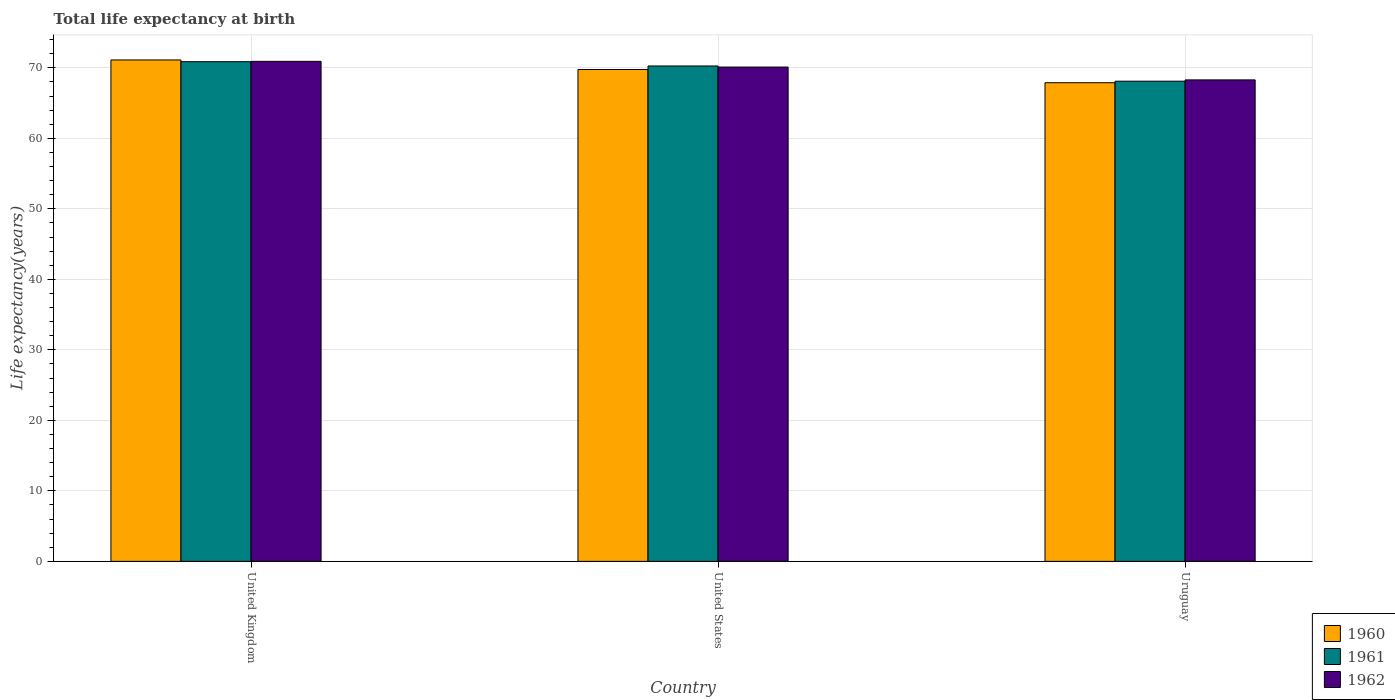How many groups of bars are there?
Offer a very short reply. 3. Are the number of bars on each tick of the X-axis equal?
Keep it short and to the point. Yes. How many bars are there on the 1st tick from the left?
Offer a very short reply. 3. How many bars are there on the 1st tick from the right?
Ensure brevity in your answer.  3. What is the life expectancy at birth in in 1961 in United Kingdom?
Offer a terse response. 70.88. Across all countries, what is the maximum life expectancy at birth in in 1962?
Your answer should be very brief. 70.93. Across all countries, what is the minimum life expectancy at birth in in 1961?
Provide a succinct answer. 68.11. In which country was the life expectancy at birth in in 1961 minimum?
Give a very brief answer. Uruguay. What is the total life expectancy at birth in in 1962 in the graph?
Provide a succinct answer. 209.34. What is the difference between the life expectancy at birth in in 1960 in United States and that in Uruguay?
Ensure brevity in your answer.  1.87. What is the difference between the life expectancy at birth in in 1961 in Uruguay and the life expectancy at birth in in 1960 in United States?
Offer a very short reply. -1.66. What is the average life expectancy at birth in in 1960 per country?
Offer a terse response. 69.6. What is the difference between the life expectancy at birth in of/in 1961 and life expectancy at birth in of/in 1960 in United States?
Give a very brief answer. 0.5. What is the ratio of the life expectancy at birth in in 1961 in United States to that in Uruguay?
Offer a terse response. 1.03. Is the difference between the life expectancy at birth in in 1961 in United States and Uruguay greater than the difference between the life expectancy at birth in in 1960 in United States and Uruguay?
Your answer should be very brief. Yes. What is the difference between the highest and the second highest life expectancy at birth in in 1962?
Offer a very short reply. 1.82. What is the difference between the highest and the lowest life expectancy at birth in in 1961?
Provide a short and direct response. 2.77. In how many countries, is the life expectancy at birth in in 1961 greater than the average life expectancy at birth in in 1961 taken over all countries?
Give a very brief answer. 2. What does the 1st bar from the left in United States represents?
Ensure brevity in your answer.  1960. Is it the case that in every country, the sum of the life expectancy at birth in in 1962 and life expectancy at birth in in 1961 is greater than the life expectancy at birth in in 1960?
Offer a very short reply. Yes. How many bars are there?
Offer a terse response. 9. Are all the bars in the graph horizontal?
Ensure brevity in your answer.  No. What is the difference between two consecutive major ticks on the Y-axis?
Make the answer very short. 10. Are the values on the major ticks of Y-axis written in scientific E-notation?
Your response must be concise. No. Where does the legend appear in the graph?
Give a very brief answer. Bottom right. How many legend labels are there?
Your response must be concise. 3. How are the legend labels stacked?
Give a very brief answer. Vertical. What is the title of the graph?
Offer a very short reply. Total life expectancy at birth. Does "2013" appear as one of the legend labels in the graph?
Offer a terse response. No. What is the label or title of the Y-axis?
Your answer should be very brief. Life expectancy(years). What is the Life expectancy(years) in 1960 in United Kingdom?
Your answer should be very brief. 71.13. What is the Life expectancy(years) in 1961 in United Kingdom?
Offer a very short reply. 70.88. What is the Life expectancy(years) of 1962 in United Kingdom?
Your answer should be compact. 70.93. What is the Life expectancy(years) of 1960 in United States?
Ensure brevity in your answer.  69.77. What is the Life expectancy(years) in 1961 in United States?
Make the answer very short. 70.27. What is the Life expectancy(years) in 1962 in United States?
Your answer should be compact. 70.12. What is the Life expectancy(years) in 1960 in Uruguay?
Provide a short and direct response. 67.9. What is the Life expectancy(years) in 1961 in Uruguay?
Provide a short and direct response. 68.11. What is the Life expectancy(years) in 1962 in Uruguay?
Make the answer very short. 68.3. Across all countries, what is the maximum Life expectancy(years) of 1960?
Your answer should be very brief. 71.13. Across all countries, what is the maximum Life expectancy(years) of 1961?
Give a very brief answer. 70.88. Across all countries, what is the maximum Life expectancy(years) in 1962?
Give a very brief answer. 70.93. Across all countries, what is the minimum Life expectancy(years) of 1960?
Ensure brevity in your answer.  67.9. Across all countries, what is the minimum Life expectancy(years) in 1961?
Keep it short and to the point. 68.11. Across all countries, what is the minimum Life expectancy(years) of 1962?
Provide a succinct answer. 68.3. What is the total Life expectancy(years) in 1960 in the graph?
Ensure brevity in your answer.  208.79. What is the total Life expectancy(years) of 1961 in the graph?
Make the answer very short. 209.26. What is the total Life expectancy(years) of 1962 in the graph?
Provide a short and direct response. 209.34. What is the difference between the Life expectancy(years) in 1960 in United Kingdom and that in United States?
Your response must be concise. 1.36. What is the difference between the Life expectancy(years) of 1961 in United Kingdom and that in United States?
Make the answer very short. 0.61. What is the difference between the Life expectancy(years) in 1962 in United Kingdom and that in United States?
Provide a succinct answer. 0.81. What is the difference between the Life expectancy(years) of 1960 in United Kingdom and that in Uruguay?
Your answer should be very brief. 3.23. What is the difference between the Life expectancy(years) of 1961 in United Kingdom and that in Uruguay?
Provide a succinct answer. 2.77. What is the difference between the Life expectancy(years) in 1962 in United Kingdom and that in Uruguay?
Give a very brief answer. 2.63. What is the difference between the Life expectancy(years) of 1960 in United States and that in Uruguay?
Keep it short and to the point. 1.87. What is the difference between the Life expectancy(years) in 1961 in United States and that in Uruguay?
Provide a succinct answer. 2.16. What is the difference between the Life expectancy(years) of 1962 in United States and that in Uruguay?
Make the answer very short. 1.82. What is the difference between the Life expectancy(years) of 1960 in United Kingdom and the Life expectancy(years) of 1961 in United States?
Provide a succinct answer. 0.86. What is the difference between the Life expectancy(years) in 1960 in United Kingdom and the Life expectancy(years) in 1962 in United States?
Keep it short and to the point. 1.01. What is the difference between the Life expectancy(years) of 1961 in United Kingdom and the Life expectancy(years) of 1962 in United States?
Keep it short and to the point. 0.76. What is the difference between the Life expectancy(years) of 1960 in United Kingdom and the Life expectancy(years) of 1961 in Uruguay?
Ensure brevity in your answer.  3.01. What is the difference between the Life expectancy(years) of 1960 in United Kingdom and the Life expectancy(years) of 1962 in Uruguay?
Provide a succinct answer. 2.83. What is the difference between the Life expectancy(years) in 1961 in United Kingdom and the Life expectancy(years) in 1962 in Uruguay?
Offer a very short reply. 2.58. What is the difference between the Life expectancy(years) of 1960 in United States and the Life expectancy(years) of 1961 in Uruguay?
Offer a very short reply. 1.66. What is the difference between the Life expectancy(years) of 1960 in United States and the Life expectancy(years) of 1962 in Uruguay?
Make the answer very short. 1.47. What is the difference between the Life expectancy(years) of 1961 in United States and the Life expectancy(years) of 1962 in Uruguay?
Provide a succinct answer. 1.97. What is the average Life expectancy(years) in 1960 per country?
Your answer should be very brief. 69.6. What is the average Life expectancy(years) in 1961 per country?
Your answer should be very brief. 69.75. What is the average Life expectancy(years) of 1962 per country?
Make the answer very short. 69.78. What is the difference between the Life expectancy(years) in 1960 and Life expectancy(years) in 1961 in United Kingdom?
Offer a very short reply. 0.25. What is the difference between the Life expectancy(years) of 1961 and Life expectancy(years) of 1962 in United Kingdom?
Offer a very short reply. -0.05. What is the difference between the Life expectancy(years) in 1960 and Life expectancy(years) in 1961 in United States?
Your answer should be very brief. -0.5. What is the difference between the Life expectancy(years) in 1960 and Life expectancy(years) in 1962 in United States?
Ensure brevity in your answer.  -0.35. What is the difference between the Life expectancy(years) of 1961 and Life expectancy(years) of 1962 in United States?
Your answer should be very brief. 0.15. What is the difference between the Life expectancy(years) of 1960 and Life expectancy(years) of 1961 in Uruguay?
Give a very brief answer. -0.22. What is the difference between the Life expectancy(years) in 1960 and Life expectancy(years) in 1962 in Uruguay?
Provide a succinct answer. -0.4. What is the difference between the Life expectancy(years) of 1961 and Life expectancy(years) of 1962 in Uruguay?
Keep it short and to the point. -0.18. What is the ratio of the Life expectancy(years) of 1960 in United Kingdom to that in United States?
Offer a very short reply. 1.02. What is the ratio of the Life expectancy(years) in 1961 in United Kingdom to that in United States?
Provide a succinct answer. 1.01. What is the ratio of the Life expectancy(years) in 1962 in United Kingdom to that in United States?
Your answer should be very brief. 1.01. What is the ratio of the Life expectancy(years) of 1960 in United Kingdom to that in Uruguay?
Give a very brief answer. 1.05. What is the ratio of the Life expectancy(years) of 1961 in United Kingdom to that in Uruguay?
Make the answer very short. 1.04. What is the ratio of the Life expectancy(years) of 1962 in United Kingdom to that in Uruguay?
Make the answer very short. 1.04. What is the ratio of the Life expectancy(years) in 1960 in United States to that in Uruguay?
Provide a short and direct response. 1.03. What is the ratio of the Life expectancy(years) in 1961 in United States to that in Uruguay?
Provide a succinct answer. 1.03. What is the ratio of the Life expectancy(years) in 1962 in United States to that in Uruguay?
Your response must be concise. 1.03. What is the difference between the highest and the second highest Life expectancy(years) of 1960?
Keep it short and to the point. 1.36. What is the difference between the highest and the second highest Life expectancy(years) in 1961?
Ensure brevity in your answer.  0.61. What is the difference between the highest and the second highest Life expectancy(years) in 1962?
Offer a very short reply. 0.81. What is the difference between the highest and the lowest Life expectancy(years) in 1960?
Ensure brevity in your answer.  3.23. What is the difference between the highest and the lowest Life expectancy(years) of 1961?
Your answer should be very brief. 2.77. What is the difference between the highest and the lowest Life expectancy(years) in 1962?
Your answer should be very brief. 2.63. 